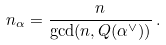Convert formula to latex. <formula><loc_0><loc_0><loc_500><loc_500>n _ { \alpha } = \frac { n } { \gcd ( n , Q ( \alpha ^ { \vee } ) ) } \, .</formula> 